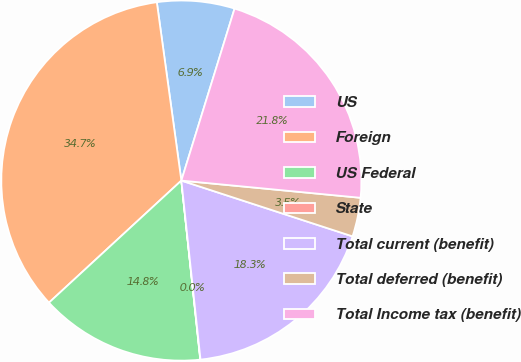<chart> <loc_0><loc_0><loc_500><loc_500><pie_chart><fcel>US<fcel>Foreign<fcel>US Federal<fcel>State<fcel>Total current (benefit)<fcel>Total deferred (benefit)<fcel>Total Income tax (benefit)<nl><fcel>6.95%<fcel>34.68%<fcel>14.82%<fcel>0.02%<fcel>18.29%<fcel>3.49%<fcel>21.75%<nl></chart> 